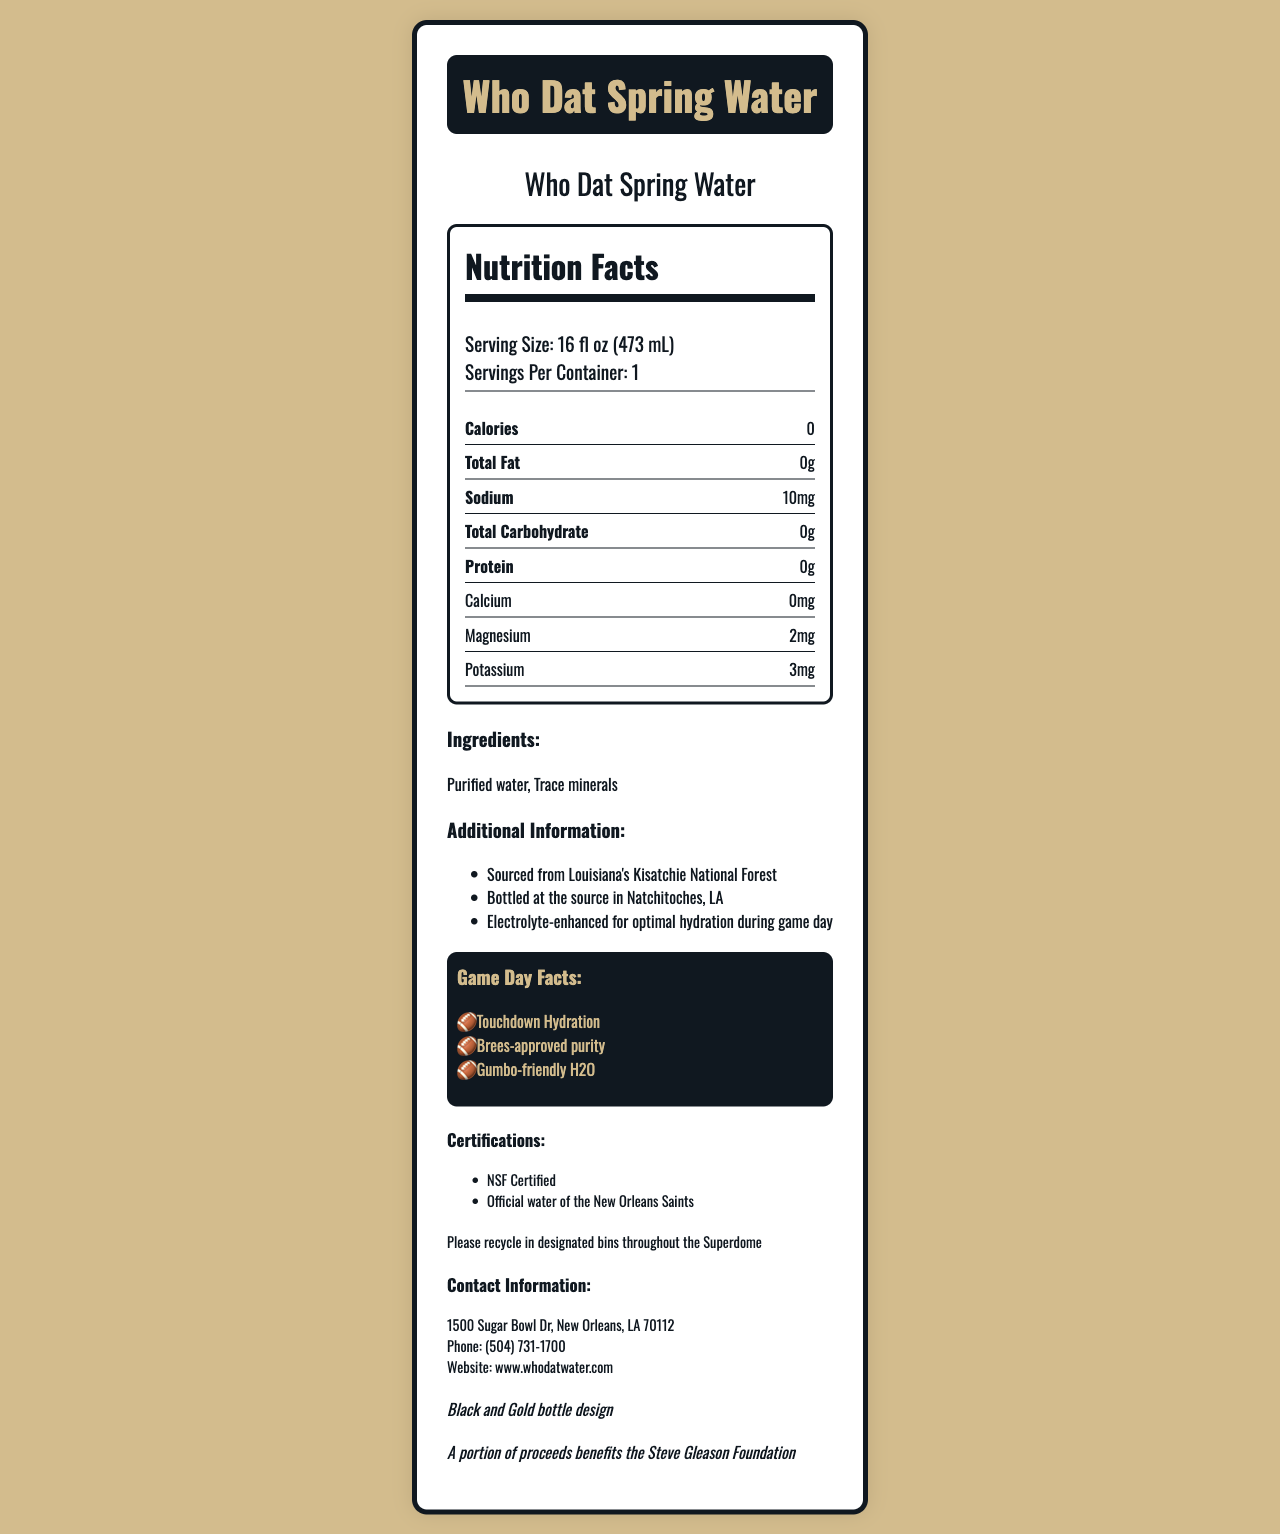what is the serving size for Who Dat Spring Water? The serving size is indicated in the Nutrition Facts section and reads "Serving Size: 16 fl oz (473 mL)."
Answer: 16 fl oz (473 mL) how many servings are there per container? The nutrition facts state "Servings Per Container: 1."
Answer: 1 what are the ingredients listed for Who Dat Spring Water? The ingredients are listed under the "Ingredients" section: "Purified water" and "Trace minerals."
Answer: Purified water, Trace minerals how much sodium does each serving of Who Dat Spring Water contain? In the Nutrition Facts section, the sodium content is listed as "10mg."
Answer: 10mg is Who Dat Spring Water sourced locally from Louisiana? The additional information section states that the water is sourced from "Louisiana's Kisatchie National Forest" and bottled at the source in "Natchitoches, LA."
Answer: Yes where can I recycle the bottle at the Superdome? The recycling information section states, "Please recycle in designated bins throughout the Superdome."
Answer: In designated bins throughout the Superdome which trace minerals are mentioned in the ingredients of Who Dat Spring Water? A. Calcium, B. Magnesium, C. Sodium The ingredients section lists "Trace minerals," and the Nutrition Facts show magnesium (2mg) and potassium (3mg) as trace minerals.
Answer: B what special edition design is mentioned for Who Dat Spring Water bottles? The special edition section mentions "Black and Gold bottle design."
Answer: Black and Gold bottle design for which foundation does a portion of the proceeds benefit? A. Drew Brees Foundation, B. Steve Gleason Foundation, C. New Orleans Children’s Hospital The charity partnership section states "A portion of proceeds benefits the Steve Gleason Foundation."
Answer: B is the Who Dat Spring Water calorie-free? The Nutrition Facts section shows "Calories: 0," indicating it is calorie-free.
Answer: Yes how does the label promote the water regarding hydration during game day? The additional information section mentions that it is "Electrolyte-enhanced for optimal hydration during game day."
Answer: Electrolyte-enhanced for optimal hydration during game day is the water "Brees-approved"? The football references section includes "Brees-approved purity," indicating endorsement by Drew Brees.
Answer: Yes what is one of the listed game day facts for Who Dat Spring Water? Under the football references section, "Touchdown Hydration" is listed as a game day fact.
Answer: Touchdown Hydration where is the company address located? The contact information section provides the address.
Answer: 1500 Sugar Bowl Dr, New Orleans, LA 70112 how much calcium does each serving contain? The Nutrition Facts section lists the calcium content as "0mg."
Answer: 0mg what certifications does Who Dat Spring Water have? The certifications section lists "NSF Certified" and "Official water of the New Orleans Saints."
Answer: NSF Certified, Official water of the New Orleans Saints describe the main idea of the document The document provides comprehensive details about Who Dat Spring Water, highlighting its nutritional information, local sourcing, electrolyte enhancements for hydration, relationship with the New Orleans Saints, and its eco-friendly and charitable initiatives.
Answer: The document contains the nutrition facts for Who Dat Spring Water, sold at the Superdome during home games. It details nutritional content, ingredients, additional product information, certifications, contact information, promotions tied to New Orleans Saints football, and environmental and charitable contributions. who developed this document using coding tools? The document does not provide any details about the creator or mention the use of coding tools for its development. The visible information is limited to product details and not the development process.
Answer: Not enough information 